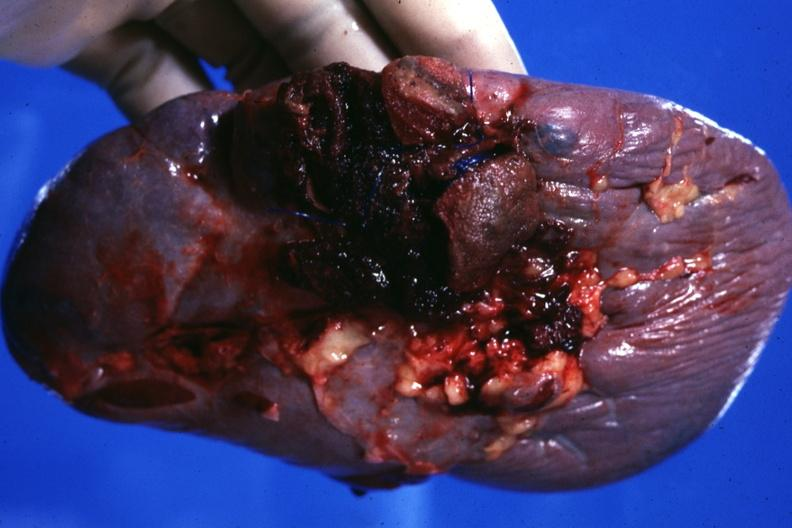s adenoma sebaceum present?
Answer the question using a single word or phrase. No 